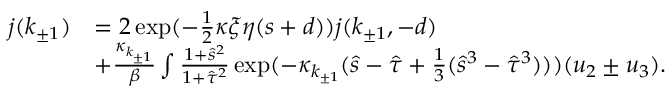Convert formula to latex. <formula><loc_0><loc_0><loc_500><loc_500>\begin{array} { r l } { j ( k _ { \pm 1 } ) } & { = 2 \exp ( - \frac { 1 } { 2 } \kappa \xi \eta ( s + d ) ) j ( k _ { \pm 1 } , - d ) } \\ & { + \frac { \kappa _ { k _ { \pm 1 } } } { \beta } \int \frac { 1 + \hat { s } ^ { 2 } } { 1 + \hat { \tau } ^ { 2 } } \exp ( - \kappa _ { k _ { \pm 1 } } ( \hat { s } - \hat { \tau } + \frac { 1 } { 3 } ( \hat { s } ^ { 3 } - \hat { \tau } ^ { 3 } ) ) ) ( u _ { 2 } \pm u _ { 3 } ) . } \end{array}</formula> 